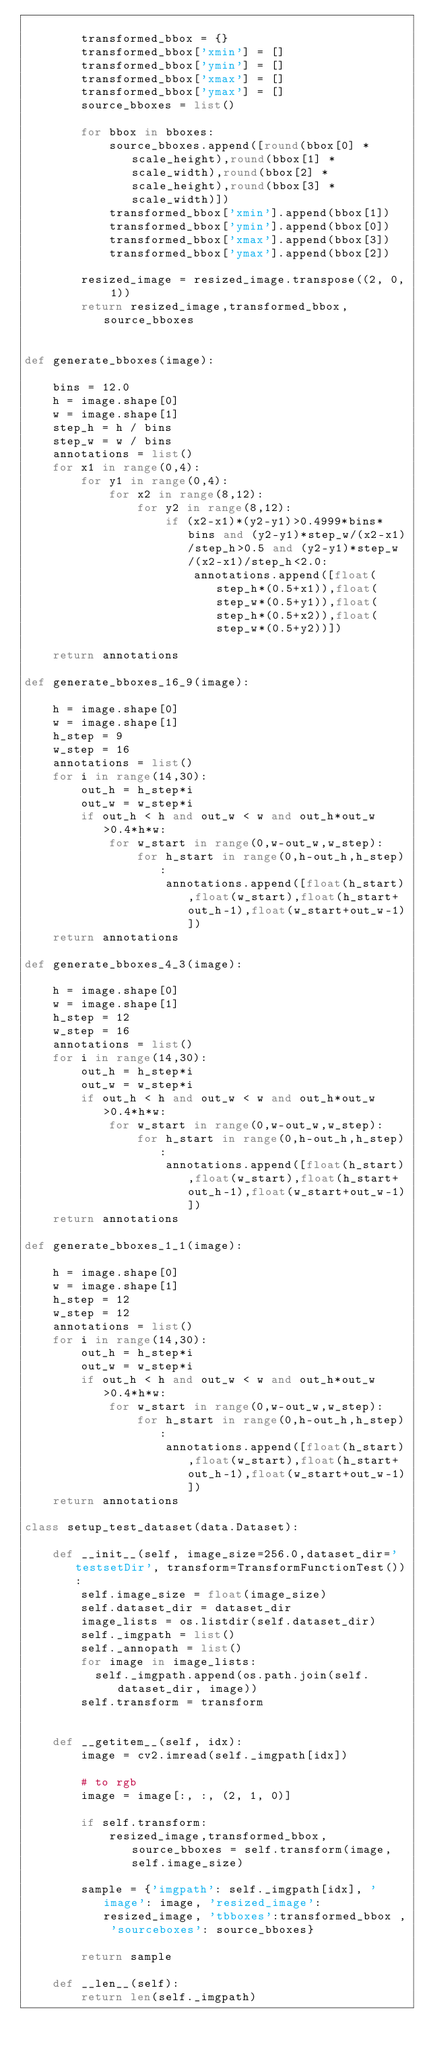Convert code to text. <code><loc_0><loc_0><loc_500><loc_500><_Python_>
        transformed_bbox = {}
        transformed_bbox['xmin'] = []
        transformed_bbox['ymin'] = []
        transformed_bbox['xmax'] = []
        transformed_bbox['ymax'] = []
        source_bboxes = list()

        for bbox in bboxes:
            source_bboxes.append([round(bbox[0] * scale_height),round(bbox[1] * scale_width),round(bbox[2] * scale_height),round(bbox[3] * scale_width)])
            transformed_bbox['xmin'].append(bbox[1])
            transformed_bbox['ymin'].append(bbox[0])
            transformed_bbox['xmax'].append(bbox[3])
            transformed_bbox['ymax'].append(bbox[2])

        resized_image = resized_image.transpose((2, 0, 1))
        return resized_image,transformed_bbox,source_bboxes


def generate_bboxes(image):

    bins = 12.0
    h = image.shape[0]
    w = image.shape[1]
    step_h = h / bins
    step_w = w / bins
    annotations = list()
    for x1 in range(0,4):
        for y1 in range(0,4):
            for x2 in range(8,12):
                for y2 in range(8,12):
                    if (x2-x1)*(y2-y1)>0.4999*bins*bins and (y2-y1)*step_w/(x2-x1)/step_h>0.5 and (y2-y1)*step_w/(x2-x1)/step_h<2.0:
                        annotations.append([float(step_h*(0.5+x1)),float(step_w*(0.5+y1)),float(step_h*(0.5+x2)),float(step_w*(0.5+y2))])

    return annotations

def generate_bboxes_16_9(image):

    h = image.shape[0]
    w = image.shape[1]
    h_step = 9
    w_step = 16
    annotations = list()
    for i in range(14,30):
        out_h = h_step*i
        out_w = w_step*i
        if out_h < h and out_w < w and out_h*out_w>0.4*h*w:
            for w_start in range(0,w-out_w,w_step):
                for h_start in range(0,h-out_h,h_step):
                    annotations.append([float(h_start),float(w_start),float(h_start+out_h-1),float(w_start+out_w-1)])
    return annotations

def generate_bboxes_4_3(image):

    h = image.shape[0]
    w = image.shape[1]
    h_step = 12
    w_step = 16
    annotations = list()
    for i in range(14,30):
        out_h = h_step*i
        out_w = w_step*i
        if out_h < h and out_w < w and out_h*out_w>0.4*h*w:
            for w_start in range(0,w-out_w,w_step):
                for h_start in range(0,h-out_h,h_step):
                    annotations.append([float(h_start),float(w_start),float(h_start+out_h-1),float(w_start+out_w-1)])
    return annotations

def generate_bboxes_1_1(image):

    h = image.shape[0]
    w = image.shape[1]
    h_step = 12
    w_step = 12
    annotations = list()
    for i in range(14,30):
        out_h = h_step*i
        out_w = w_step*i
        if out_h < h and out_w < w and out_h*out_w>0.4*h*w:
            for w_start in range(0,w-out_w,w_step):
                for h_start in range(0,h-out_h,h_step):
                    annotations.append([float(h_start),float(w_start),float(h_start+out_h-1),float(w_start+out_w-1)])
    return annotations

class setup_test_dataset(data.Dataset):

    def __init__(self, image_size=256.0,dataset_dir='testsetDir', transform=TransformFunctionTest()):
        self.image_size = float(image_size)
        self.dataset_dir = dataset_dir
        image_lists = os.listdir(self.dataset_dir)
        self._imgpath = list()
        self._annopath = list()
        for image in image_lists:
          self._imgpath.append(os.path.join(self.dataset_dir, image))
        self.transform = transform


    def __getitem__(self, idx):
        image = cv2.imread(self._imgpath[idx])

        # to rgb
        image = image[:, :, (2, 1, 0)]

        if self.transform:
            resized_image,transformed_bbox,source_bboxes = self.transform(image,self.image_size)

        sample = {'imgpath': self._imgpath[idx], 'image': image, 'resized_image': resized_image, 'tbboxes':transformed_bbox , 'sourceboxes': source_bboxes}

        return sample

    def __len__(self):
        return len(self._imgpath)

</code> 